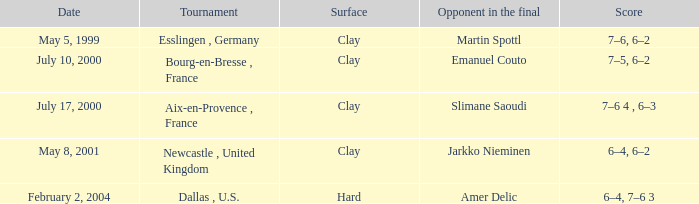Could you parse the entire table as a dict? {'header': ['Date', 'Tournament', 'Surface', 'Opponent in the final', 'Score'], 'rows': [['May 5, 1999', 'Esslingen , Germany', 'Clay', 'Martin Spottl', '7–6, 6–2'], ['July 10, 2000', 'Bourg-en-Bresse , France', 'Clay', 'Emanuel Couto', '7–5, 6–2'], ['July 17, 2000', 'Aix-en-Provence , France', 'Clay', 'Slimane Saoudi', '7–6 4 , 6–3'], ['May 8, 2001', 'Newcastle , United Kingdom', 'Clay', 'Jarkko Nieminen', '6–4, 6–2'], ['February 2, 2004', 'Dallas , U.S.', 'Hard', 'Amer Delic', '6–4, 7–6 3']]} What is the Date of the game with a Score of 6–4, 6–2? May 8, 2001. 